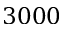<formula> <loc_0><loc_0><loc_500><loc_500>3 0 0 0</formula> 